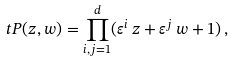<formula> <loc_0><loc_0><loc_500><loc_500>\ t P ( z , w ) = \prod _ { i , j = 1 } ^ { d } ( \varepsilon ^ { i } \, z + \varepsilon ^ { j } \, w + 1 ) \, ,</formula> 